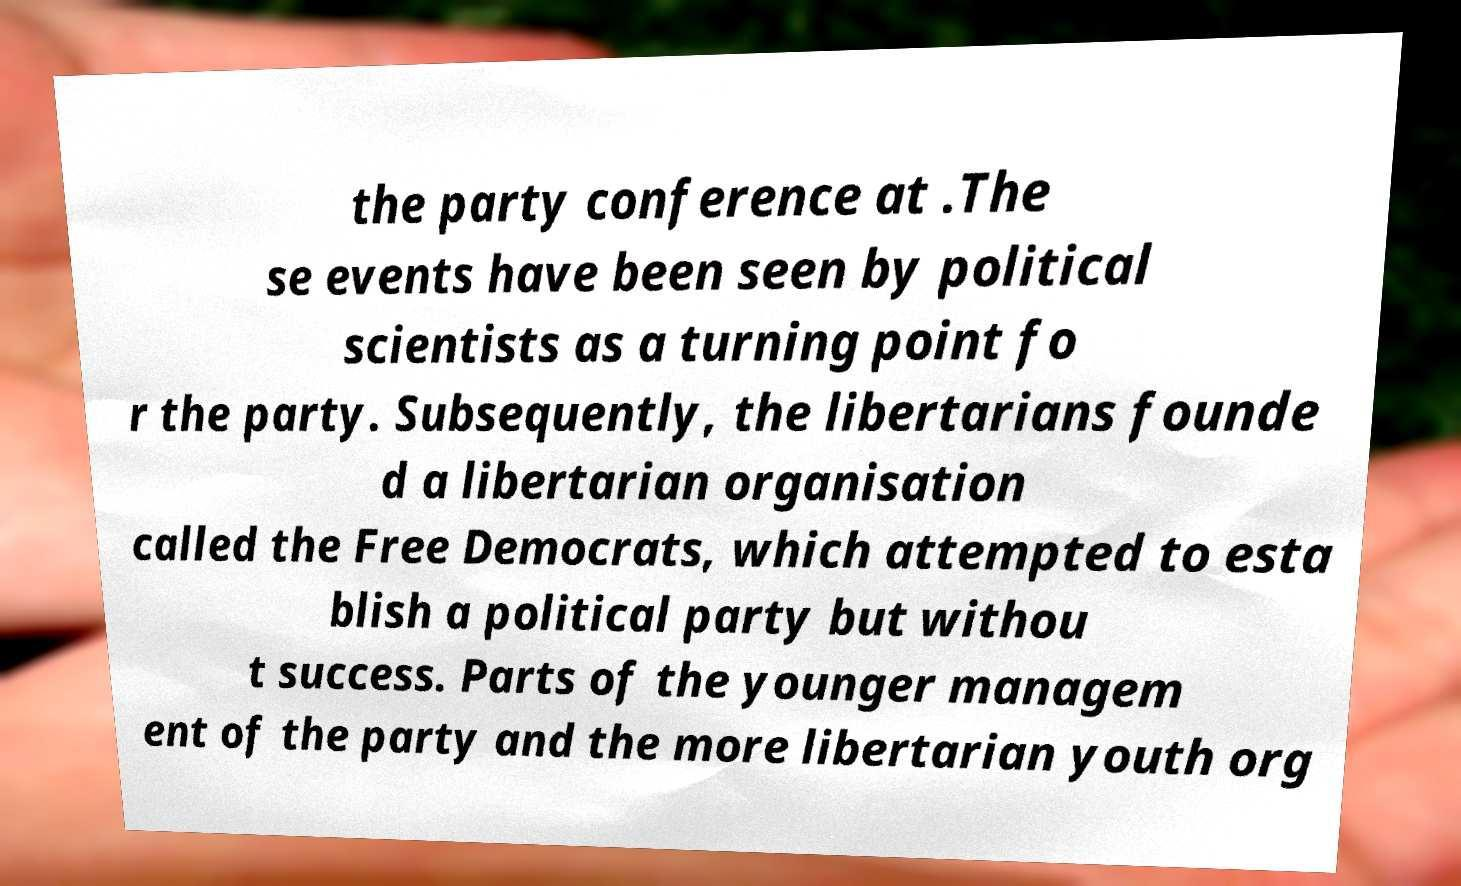Can you read and provide the text displayed in the image?This photo seems to have some interesting text. Can you extract and type it out for me? the party conference at .The se events have been seen by political scientists as a turning point fo r the party. Subsequently, the libertarians founde d a libertarian organisation called the Free Democrats, which attempted to esta blish a political party but withou t success. Parts of the younger managem ent of the party and the more libertarian youth org 